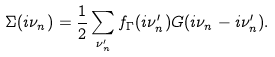<formula> <loc_0><loc_0><loc_500><loc_500>\Sigma ( i \nu _ { n } ) = \frac { 1 } { 2 } \sum _ { \nu _ { n } ^ { \prime } } f _ { \Gamma } ( i \nu _ { n } ^ { \prime } ) G ( i \nu _ { n } - i \nu _ { n } ^ { \prime } ) .</formula> 